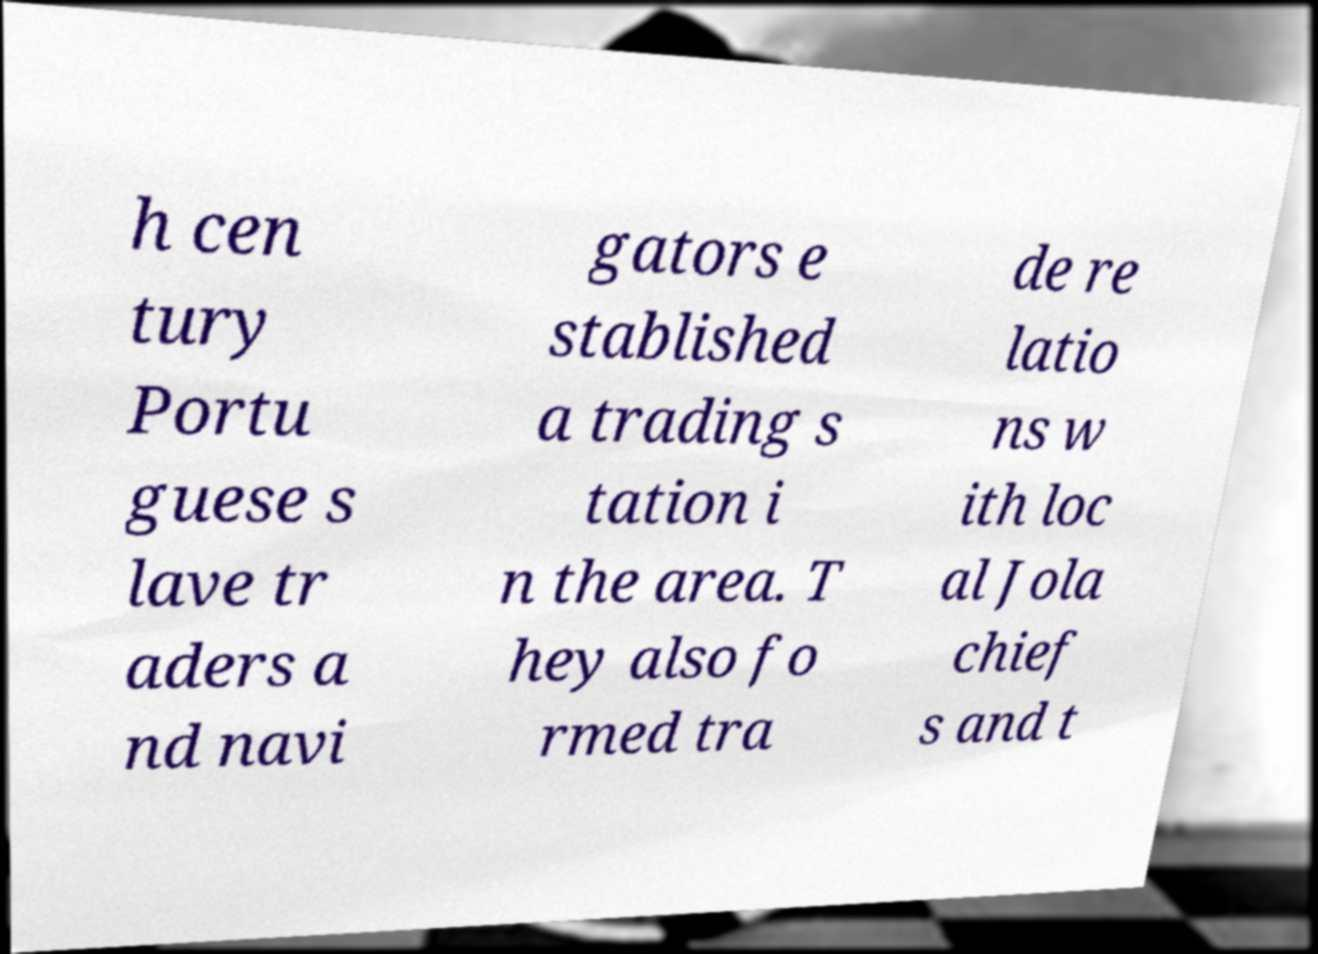For documentation purposes, I need the text within this image transcribed. Could you provide that? h cen tury Portu guese s lave tr aders a nd navi gators e stablished a trading s tation i n the area. T hey also fo rmed tra de re latio ns w ith loc al Jola chief s and t 